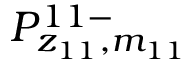Convert formula to latex. <formula><loc_0><loc_0><loc_500><loc_500>P _ { z _ { 1 1 } , m _ { 1 1 } } ^ { 1 1 - }</formula> 